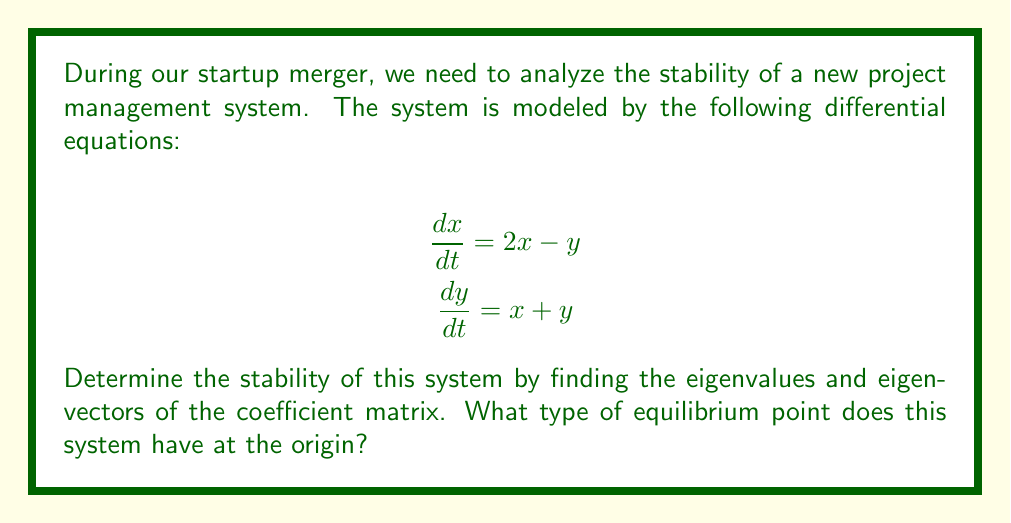Show me your answer to this math problem. 1. First, we need to identify the coefficient matrix A from the given system of equations:

   $$A = \begin{bmatrix}
   2 & -1 \\
   1 & 1
   \end{bmatrix}$$

2. To find the eigenvalues, we solve the characteristic equation:
   $$det(A - \lambda I) = 0$$
   
   $$\begin{vmatrix}
   2-\lambda & -1 \\
   1 & 1-\lambda
   \end{vmatrix} = 0$$
   
   $$(2-\lambda)(1-\lambda) + 1 = 0$$
   
   $$\lambda^2 - 3\lambda + 1 = 0$$

3. Solving this quadratic equation:
   $$\lambda = \frac{3 \pm \sqrt{9 - 4}}{2} = \frac{3 \pm \sqrt{5}}{2}$$

4. The eigenvalues are:
   $$\lambda_1 = \frac{3 + \sqrt{5}}{2} \approx 2.618$$
   $$\lambda_2 = \frac{3 - \sqrt{5}}{2} \approx 0.382$$

5. Both eigenvalues are real and positive, with $\lambda_1 > 1$ and $0 < \lambda_2 < 1$.

6. To find the eigenvectors, we solve $(A - \lambda I)v = 0$ for each eigenvalue:

   For $\lambda_1$:
   $$\begin{bmatrix}
   2-\lambda_1 & -1 \\
   1 & 1-\lambda_1
   \end{bmatrix}\begin{bmatrix}
   v_1 \\
   v_2
   \end{bmatrix} = \begin{bmatrix}
   0 \\
   0
   \end{bmatrix}$$

   This gives us the eigenvector $v_1 = \begin{bmatrix}
   1 \\
   \lambda_1 - 2
   \end{bmatrix}$.

   Similarly, for $\lambda_2$, we get $v_2 = \begin{bmatrix}
   1 \\
   \lambda_2 - 2
   \end{bmatrix}$.

7. The stability of the system is determined by the eigenvalues:
   - $\lambda_1 > 1$ indicates exponential growth in the direction of $v_1$.
   - $0 < \lambda_2 < 1$ indicates decay in the direction of $v_2$.

8. Since one eigenvalue is greater than 1 and the other is between 0 and 1, the equilibrium point at the origin is an unstable saddle point.
Answer: Unstable saddle point 